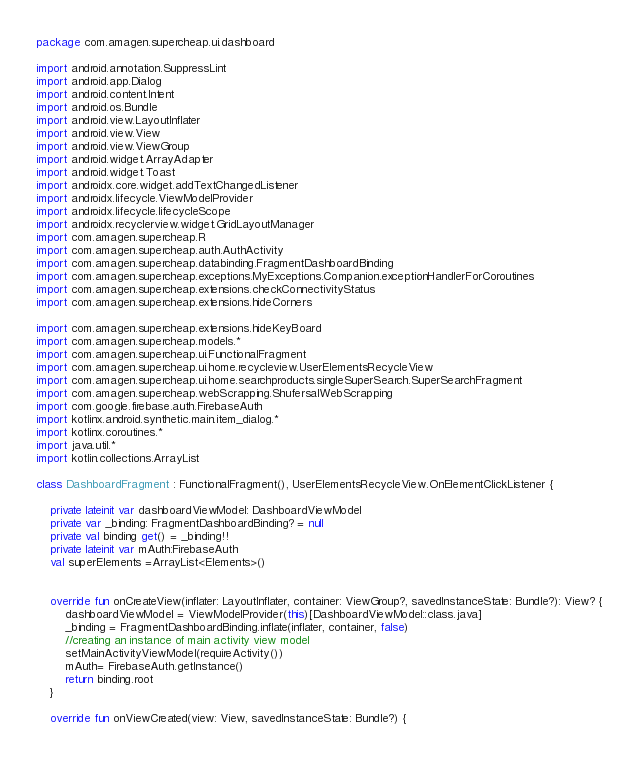<code> <loc_0><loc_0><loc_500><loc_500><_Kotlin_>package com.amagen.supercheap.ui.dashboard

import android.annotation.SuppressLint
import android.app.Dialog
import android.content.Intent
import android.os.Bundle
import android.view.LayoutInflater
import android.view.View
import android.view.ViewGroup
import android.widget.ArrayAdapter
import android.widget.Toast
import androidx.core.widget.addTextChangedListener
import androidx.lifecycle.ViewModelProvider
import androidx.lifecycle.lifecycleScope
import androidx.recyclerview.widget.GridLayoutManager
import com.amagen.supercheap.R
import com.amagen.supercheap.auth.AuthActivity
import com.amagen.supercheap.databinding.FragmentDashboardBinding
import com.amagen.supercheap.exceptions.MyExceptions.Companion.exceptionHandlerForCoroutines
import com.amagen.supercheap.extensions.checkConnectivityStatus
import com.amagen.supercheap.extensions.hideCorners

import com.amagen.supercheap.extensions.hideKeyBoard
import com.amagen.supercheap.models.*
import com.amagen.supercheap.ui.FunctionalFragment
import com.amagen.supercheap.ui.home.recycleview.UserElementsRecycleView
import com.amagen.supercheap.ui.home.searchproducts.singleSuperSearch.SuperSearchFragment
import com.amagen.supercheap.webScrapping.ShufersalWebScrapping
import com.google.firebase.auth.FirebaseAuth
import kotlinx.android.synthetic.main.item_dialog.*
import kotlinx.coroutines.*
import java.util.*
import kotlin.collections.ArrayList

class DashboardFragment : FunctionalFragment(), UserElementsRecycleView.OnElementClickListener {

    private lateinit var dashboardViewModel: DashboardViewModel
    private var _binding: FragmentDashboardBinding? = null
    private val binding get() = _binding!!
    private lateinit var mAuth:FirebaseAuth
    val superElements =ArrayList<Elements>()


    override fun onCreateView(inflater: LayoutInflater, container: ViewGroup?, savedInstanceState: Bundle?): View? {
        dashboardViewModel = ViewModelProvider(this)[DashboardViewModel::class.java]
        _binding = FragmentDashboardBinding.inflate(inflater, container, false)
        //creating an instance of main activity view model
        setMainActivityViewModel(requireActivity())
        mAuth= FirebaseAuth.getInstance()
        return binding.root
    }

    override fun onViewCreated(view: View, savedInstanceState: Bundle?) {</code> 